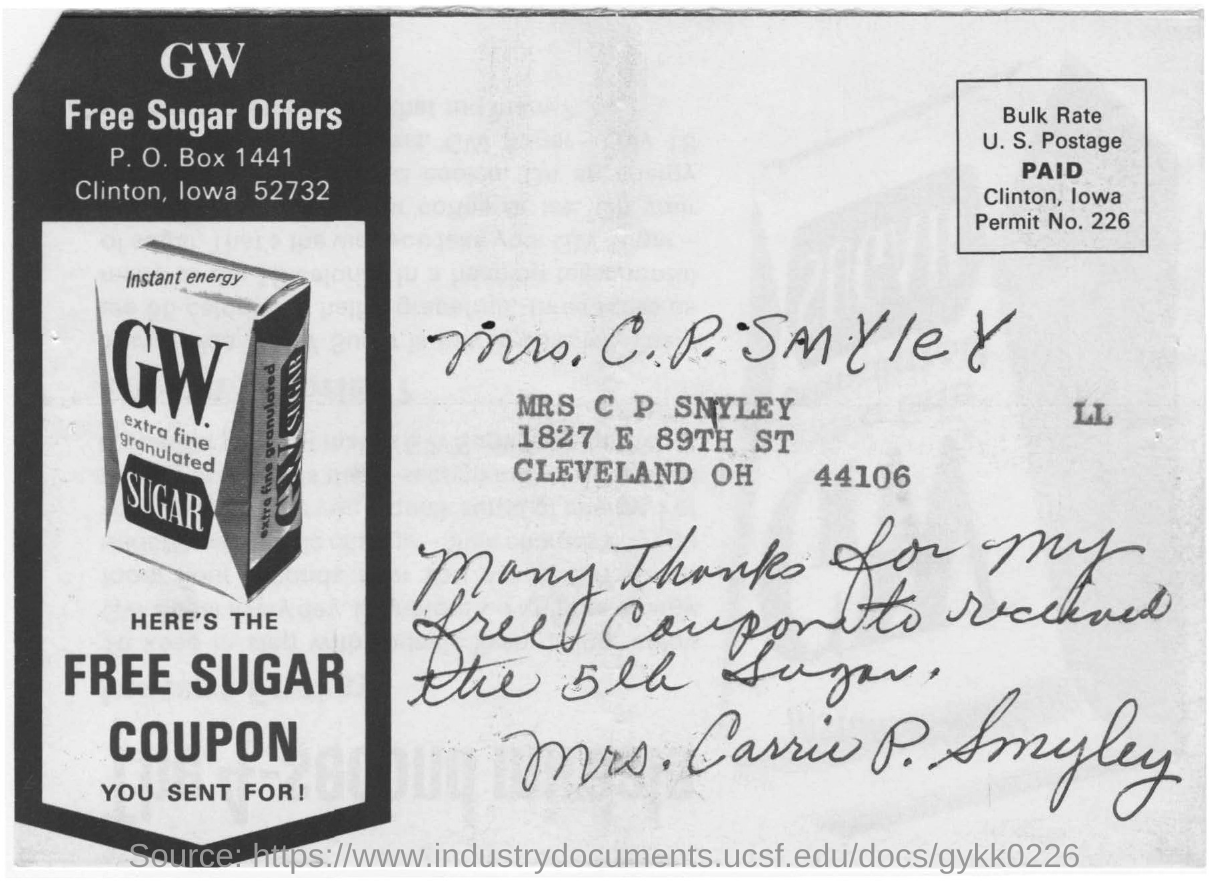What is the name of the company?
Make the answer very short. GW. What is the name mentioned in this document?
Keep it short and to the point. Mrs. Carrie P. Smyley. What is this company offering according to the picture?
Provide a succinct answer. FREE SUGAR COUPON. 